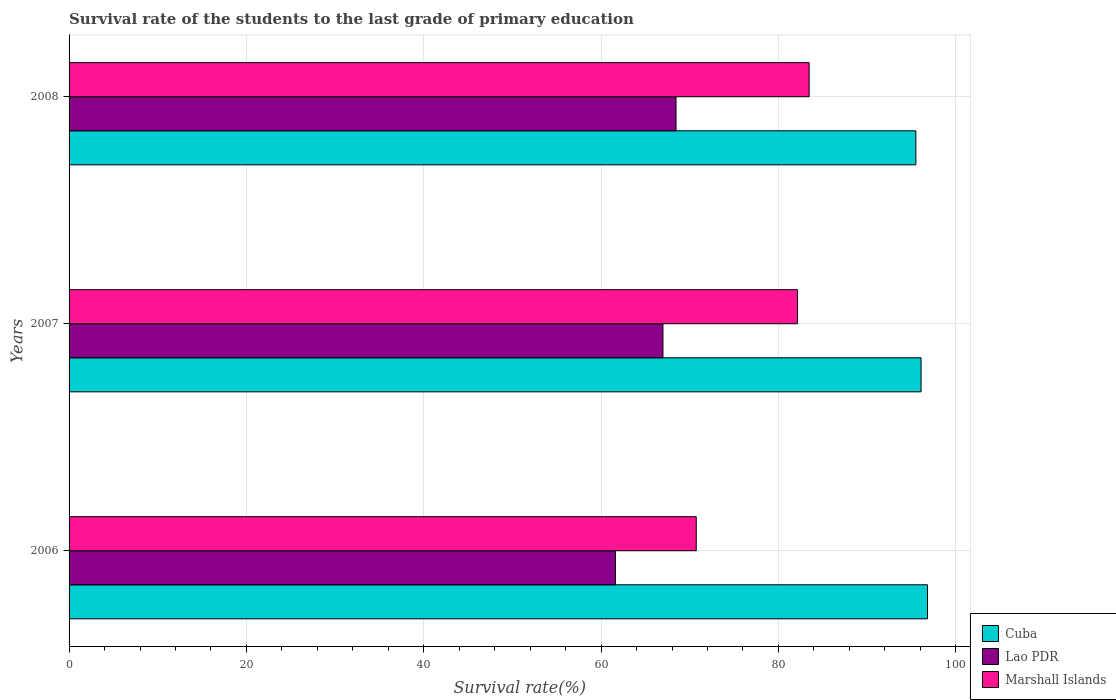How many bars are there on the 1st tick from the top?
Give a very brief answer. 3. What is the label of the 3rd group of bars from the top?
Give a very brief answer. 2006. What is the survival rate of the students in Marshall Islands in 2007?
Your response must be concise. 82.15. Across all years, what is the maximum survival rate of the students in Cuba?
Keep it short and to the point. 96.82. Across all years, what is the minimum survival rate of the students in Marshall Islands?
Offer a very short reply. 70.73. In which year was the survival rate of the students in Cuba maximum?
Provide a succinct answer. 2006. What is the total survival rate of the students in Cuba in the graph?
Ensure brevity in your answer.  288.4. What is the difference between the survival rate of the students in Lao PDR in 2007 and that in 2008?
Your answer should be very brief. -1.48. What is the difference between the survival rate of the students in Marshall Islands in 2006 and the survival rate of the students in Lao PDR in 2008?
Give a very brief answer. 2.28. What is the average survival rate of the students in Marshall Islands per year?
Your answer should be compact. 78.78. In the year 2006, what is the difference between the survival rate of the students in Marshall Islands and survival rate of the students in Lao PDR?
Provide a succinct answer. 9.12. In how many years, is the survival rate of the students in Lao PDR greater than 40 %?
Keep it short and to the point. 3. What is the ratio of the survival rate of the students in Marshall Islands in 2006 to that in 2007?
Offer a terse response. 0.86. What is the difference between the highest and the second highest survival rate of the students in Lao PDR?
Offer a very short reply. 1.48. What is the difference between the highest and the lowest survival rate of the students in Lao PDR?
Keep it short and to the point. 6.84. In how many years, is the survival rate of the students in Marshall Islands greater than the average survival rate of the students in Marshall Islands taken over all years?
Your answer should be very brief. 2. What does the 1st bar from the top in 2008 represents?
Make the answer very short. Marshall Islands. What does the 2nd bar from the bottom in 2006 represents?
Keep it short and to the point. Lao PDR. How many years are there in the graph?
Provide a short and direct response. 3. What is the difference between two consecutive major ticks on the X-axis?
Offer a very short reply. 20. Does the graph contain grids?
Provide a short and direct response. Yes. Where does the legend appear in the graph?
Offer a very short reply. Bottom right. How many legend labels are there?
Offer a very short reply. 3. How are the legend labels stacked?
Your response must be concise. Vertical. What is the title of the graph?
Your answer should be compact. Survival rate of the students to the last grade of primary education. Does "Korea (Democratic)" appear as one of the legend labels in the graph?
Give a very brief answer. No. What is the label or title of the X-axis?
Keep it short and to the point. Survival rate(%). What is the Survival rate(%) of Cuba in 2006?
Ensure brevity in your answer.  96.82. What is the Survival rate(%) in Lao PDR in 2006?
Offer a terse response. 61.61. What is the Survival rate(%) of Marshall Islands in 2006?
Offer a very short reply. 70.73. What is the Survival rate(%) of Cuba in 2007?
Offer a terse response. 96.09. What is the Survival rate(%) of Lao PDR in 2007?
Make the answer very short. 66.98. What is the Survival rate(%) of Marshall Islands in 2007?
Offer a terse response. 82.15. What is the Survival rate(%) in Cuba in 2008?
Your answer should be very brief. 95.5. What is the Survival rate(%) of Lao PDR in 2008?
Offer a very short reply. 68.45. What is the Survival rate(%) of Marshall Islands in 2008?
Give a very brief answer. 83.47. Across all years, what is the maximum Survival rate(%) of Cuba?
Ensure brevity in your answer.  96.82. Across all years, what is the maximum Survival rate(%) in Lao PDR?
Offer a very short reply. 68.45. Across all years, what is the maximum Survival rate(%) of Marshall Islands?
Offer a terse response. 83.47. Across all years, what is the minimum Survival rate(%) of Cuba?
Provide a short and direct response. 95.5. Across all years, what is the minimum Survival rate(%) in Lao PDR?
Offer a terse response. 61.61. Across all years, what is the minimum Survival rate(%) of Marshall Islands?
Provide a succinct answer. 70.73. What is the total Survival rate(%) of Cuba in the graph?
Ensure brevity in your answer.  288.4. What is the total Survival rate(%) in Lao PDR in the graph?
Keep it short and to the point. 197.04. What is the total Survival rate(%) in Marshall Islands in the graph?
Your answer should be compact. 236.35. What is the difference between the Survival rate(%) in Cuba in 2006 and that in 2007?
Your answer should be very brief. 0.73. What is the difference between the Survival rate(%) of Lao PDR in 2006 and that in 2007?
Make the answer very short. -5.36. What is the difference between the Survival rate(%) in Marshall Islands in 2006 and that in 2007?
Give a very brief answer. -11.42. What is the difference between the Survival rate(%) of Cuba in 2006 and that in 2008?
Provide a succinct answer. 1.32. What is the difference between the Survival rate(%) in Lao PDR in 2006 and that in 2008?
Keep it short and to the point. -6.84. What is the difference between the Survival rate(%) of Marshall Islands in 2006 and that in 2008?
Offer a terse response. -12.74. What is the difference between the Survival rate(%) in Cuba in 2007 and that in 2008?
Offer a very short reply. 0.59. What is the difference between the Survival rate(%) of Lao PDR in 2007 and that in 2008?
Ensure brevity in your answer.  -1.48. What is the difference between the Survival rate(%) in Marshall Islands in 2007 and that in 2008?
Make the answer very short. -1.32. What is the difference between the Survival rate(%) of Cuba in 2006 and the Survival rate(%) of Lao PDR in 2007?
Your answer should be compact. 29.84. What is the difference between the Survival rate(%) in Cuba in 2006 and the Survival rate(%) in Marshall Islands in 2007?
Provide a short and direct response. 14.67. What is the difference between the Survival rate(%) in Lao PDR in 2006 and the Survival rate(%) in Marshall Islands in 2007?
Ensure brevity in your answer.  -20.53. What is the difference between the Survival rate(%) in Cuba in 2006 and the Survival rate(%) in Lao PDR in 2008?
Ensure brevity in your answer.  28.36. What is the difference between the Survival rate(%) in Cuba in 2006 and the Survival rate(%) in Marshall Islands in 2008?
Ensure brevity in your answer.  13.35. What is the difference between the Survival rate(%) in Lao PDR in 2006 and the Survival rate(%) in Marshall Islands in 2008?
Your answer should be compact. -21.86. What is the difference between the Survival rate(%) in Cuba in 2007 and the Survival rate(%) in Lao PDR in 2008?
Provide a succinct answer. 27.63. What is the difference between the Survival rate(%) in Cuba in 2007 and the Survival rate(%) in Marshall Islands in 2008?
Provide a short and direct response. 12.62. What is the difference between the Survival rate(%) in Lao PDR in 2007 and the Survival rate(%) in Marshall Islands in 2008?
Your response must be concise. -16.49. What is the average Survival rate(%) in Cuba per year?
Your answer should be very brief. 96.13. What is the average Survival rate(%) in Lao PDR per year?
Your answer should be very brief. 65.68. What is the average Survival rate(%) of Marshall Islands per year?
Provide a succinct answer. 78.78. In the year 2006, what is the difference between the Survival rate(%) in Cuba and Survival rate(%) in Lao PDR?
Offer a terse response. 35.2. In the year 2006, what is the difference between the Survival rate(%) of Cuba and Survival rate(%) of Marshall Islands?
Provide a short and direct response. 26.08. In the year 2006, what is the difference between the Survival rate(%) of Lao PDR and Survival rate(%) of Marshall Islands?
Ensure brevity in your answer.  -9.12. In the year 2007, what is the difference between the Survival rate(%) of Cuba and Survival rate(%) of Lao PDR?
Offer a very short reply. 29.11. In the year 2007, what is the difference between the Survival rate(%) in Cuba and Survival rate(%) in Marshall Islands?
Make the answer very short. 13.94. In the year 2007, what is the difference between the Survival rate(%) in Lao PDR and Survival rate(%) in Marshall Islands?
Provide a short and direct response. -15.17. In the year 2008, what is the difference between the Survival rate(%) of Cuba and Survival rate(%) of Lao PDR?
Offer a very short reply. 27.05. In the year 2008, what is the difference between the Survival rate(%) in Cuba and Survival rate(%) in Marshall Islands?
Ensure brevity in your answer.  12.03. In the year 2008, what is the difference between the Survival rate(%) in Lao PDR and Survival rate(%) in Marshall Islands?
Provide a succinct answer. -15.02. What is the ratio of the Survival rate(%) of Cuba in 2006 to that in 2007?
Offer a very short reply. 1.01. What is the ratio of the Survival rate(%) in Lao PDR in 2006 to that in 2007?
Provide a short and direct response. 0.92. What is the ratio of the Survival rate(%) of Marshall Islands in 2006 to that in 2007?
Give a very brief answer. 0.86. What is the ratio of the Survival rate(%) of Cuba in 2006 to that in 2008?
Make the answer very short. 1.01. What is the ratio of the Survival rate(%) in Lao PDR in 2006 to that in 2008?
Provide a short and direct response. 0.9. What is the ratio of the Survival rate(%) of Marshall Islands in 2006 to that in 2008?
Make the answer very short. 0.85. What is the ratio of the Survival rate(%) of Cuba in 2007 to that in 2008?
Your answer should be very brief. 1.01. What is the ratio of the Survival rate(%) in Lao PDR in 2007 to that in 2008?
Ensure brevity in your answer.  0.98. What is the ratio of the Survival rate(%) of Marshall Islands in 2007 to that in 2008?
Ensure brevity in your answer.  0.98. What is the difference between the highest and the second highest Survival rate(%) of Cuba?
Offer a very short reply. 0.73. What is the difference between the highest and the second highest Survival rate(%) in Lao PDR?
Ensure brevity in your answer.  1.48. What is the difference between the highest and the second highest Survival rate(%) in Marshall Islands?
Keep it short and to the point. 1.32. What is the difference between the highest and the lowest Survival rate(%) of Cuba?
Your answer should be compact. 1.32. What is the difference between the highest and the lowest Survival rate(%) in Lao PDR?
Your answer should be very brief. 6.84. What is the difference between the highest and the lowest Survival rate(%) in Marshall Islands?
Provide a short and direct response. 12.74. 